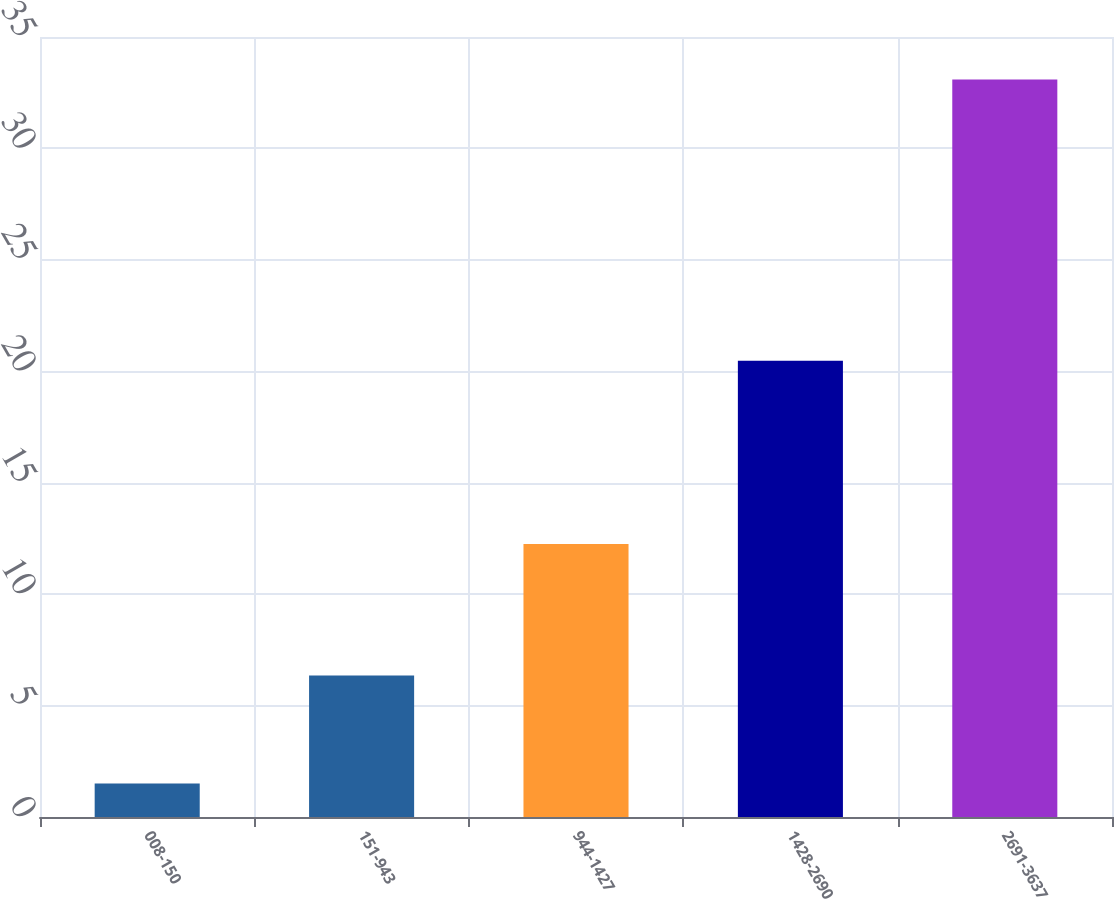Convert chart. <chart><loc_0><loc_0><loc_500><loc_500><bar_chart><fcel>008-150<fcel>151-943<fcel>944-1427<fcel>1428-2690<fcel>2691-3637<nl><fcel>1.5<fcel>6.35<fcel>12.25<fcel>20.47<fcel>33.09<nl></chart> 